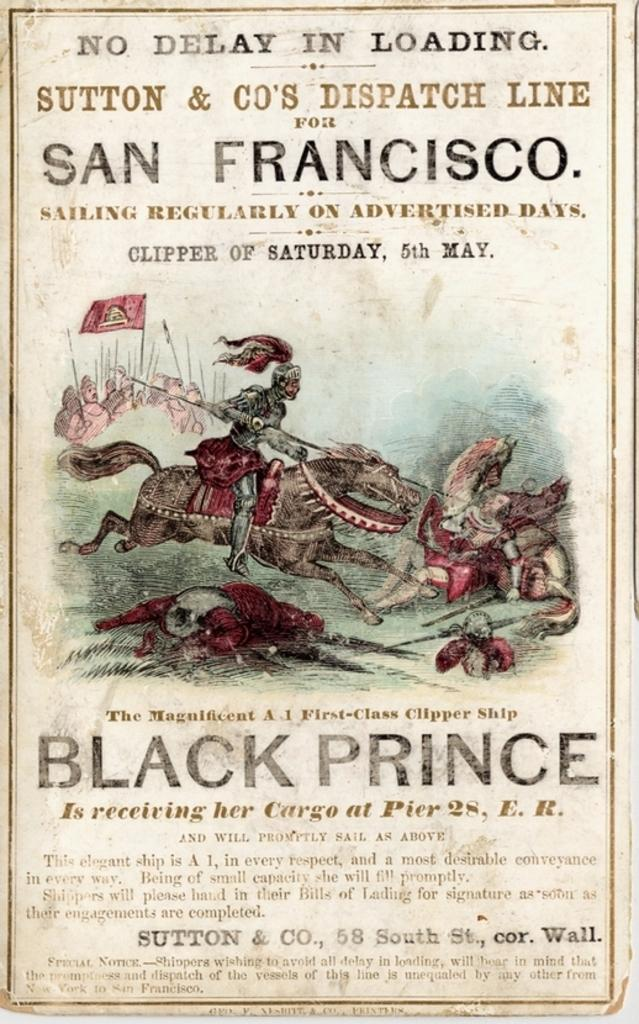<image>
Summarize the visual content of the image. A old advertisement from San Francisco displays a new sailing method. 